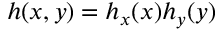Convert formula to latex. <formula><loc_0><loc_0><loc_500><loc_500>h ( x , y ) = h _ { x } ( x ) h _ { y } ( y )</formula> 